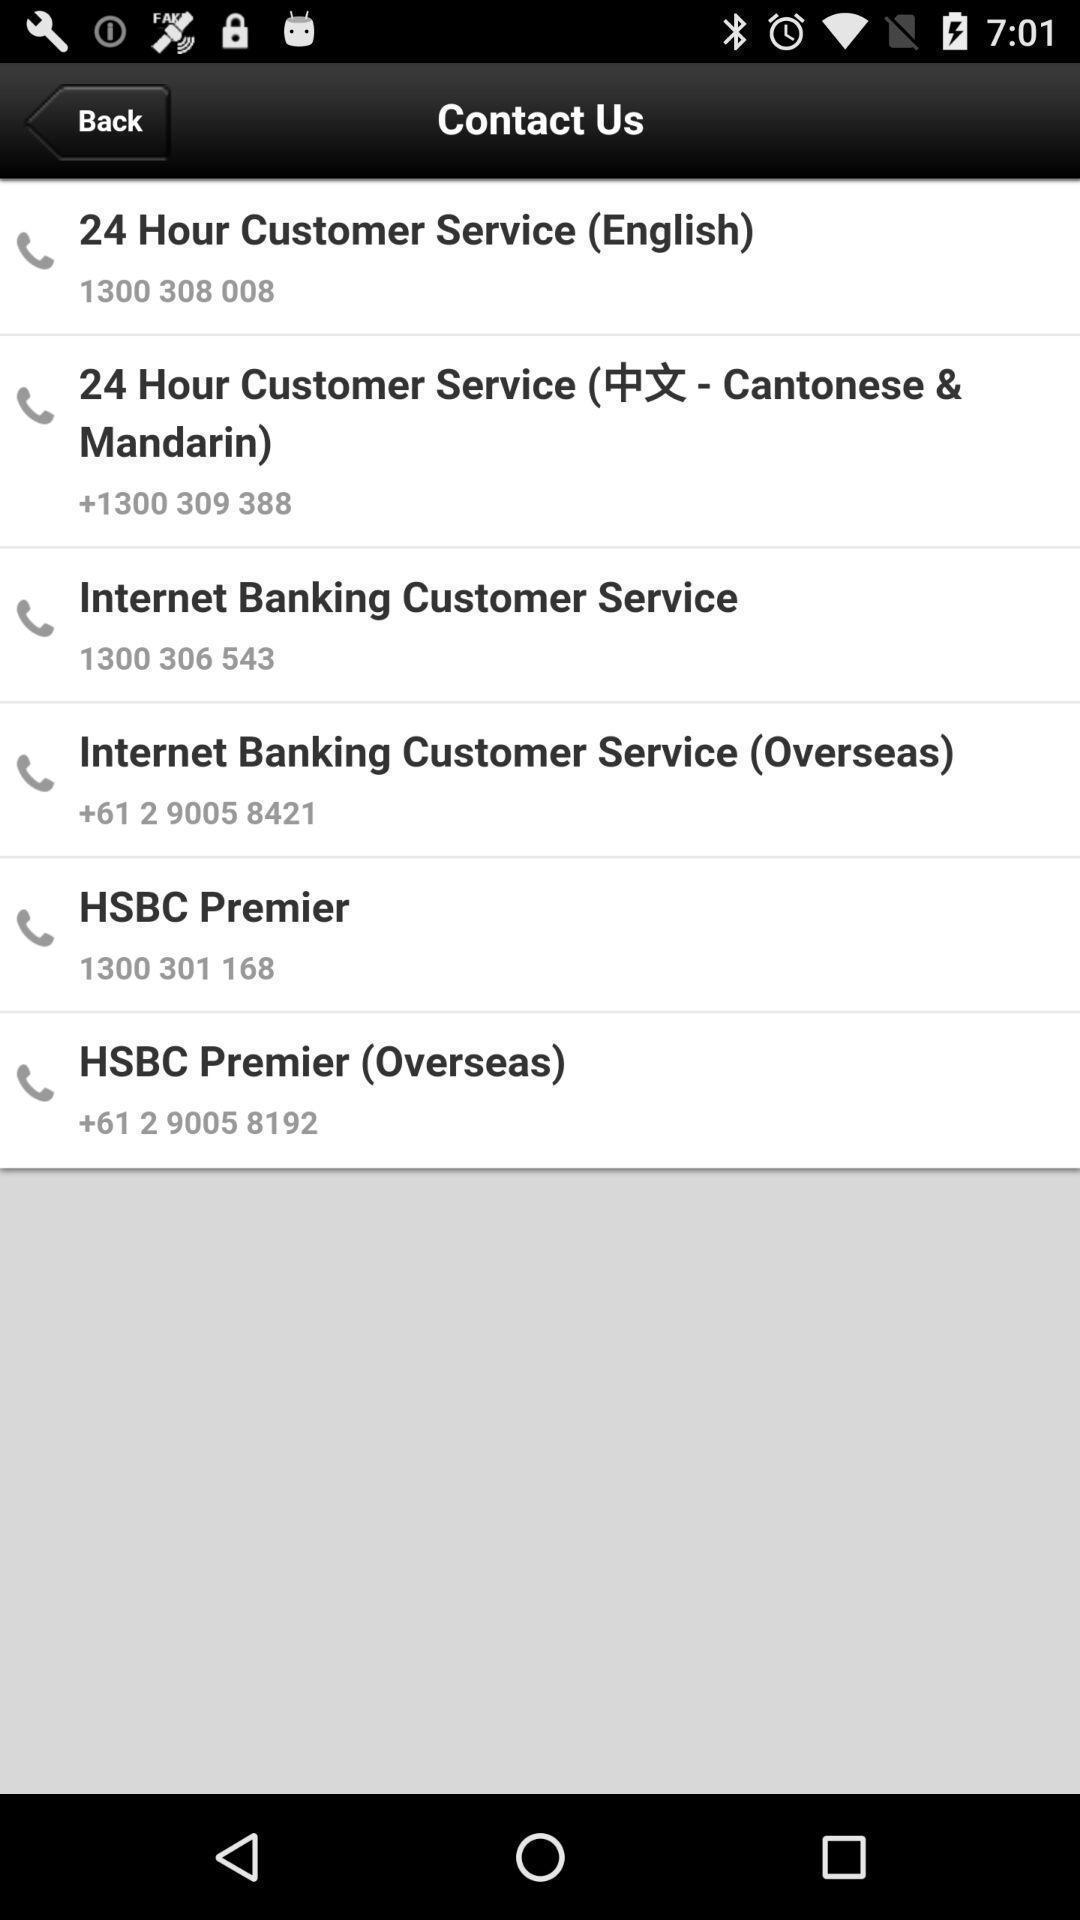Provide a description of this screenshot. Page displaying with list of different contacts. 